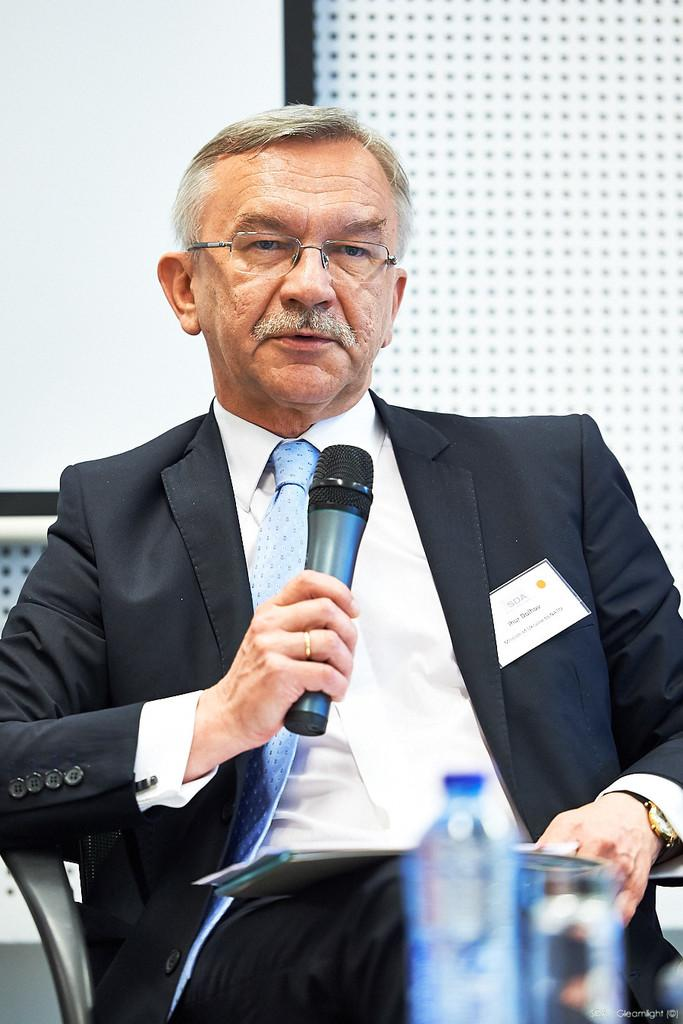What is the person in the image wearing? The person is wearing a black suit. What is the person holding in the image? The person is holding a microphone. What can be seen in the foreground of the image? There is a water bottle and a glass in the foreground of the image. What type of crook is visible in the image? There is no crook present in the image. What kind of chain is being used by the person in the image? The person in the image is not using any chain; they are holding a microphone. 